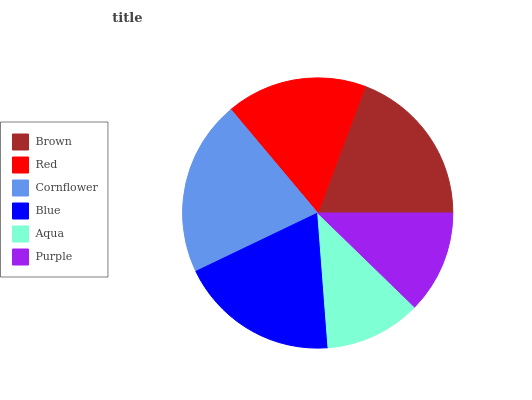Is Aqua the minimum?
Answer yes or no. Yes. Is Cornflower the maximum?
Answer yes or no. Yes. Is Red the minimum?
Answer yes or no. No. Is Red the maximum?
Answer yes or no. No. Is Brown greater than Red?
Answer yes or no. Yes. Is Red less than Brown?
Answer yes or no. Yes. Is Red greater than Brown?
Answer yes or no. No. Is Brown less than Red?
Answer yes or no. No. Is Blue the high median?
Answer yes or no. Yes. Is Red the low median?
Answer yes or no. Yes. Is Purple the high median?
Answer yes or no. No. Is Aqua the low median?
Answer yes or no. No. 